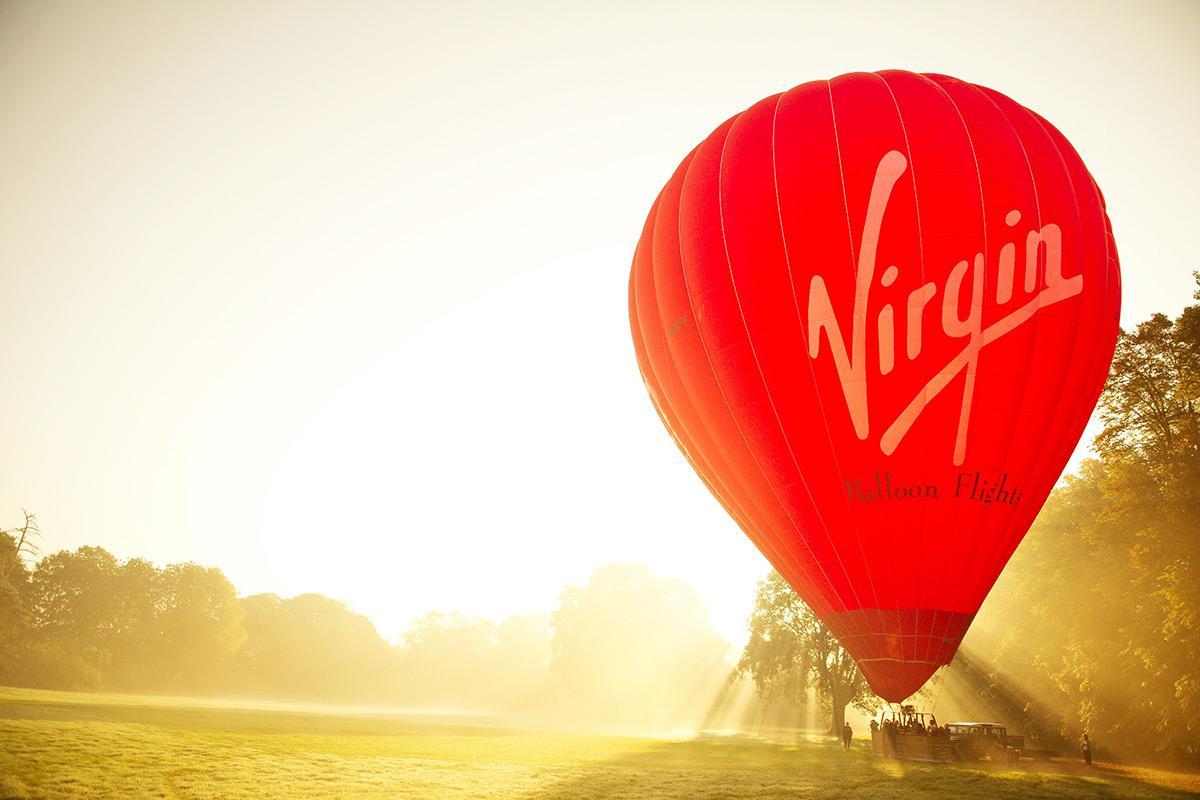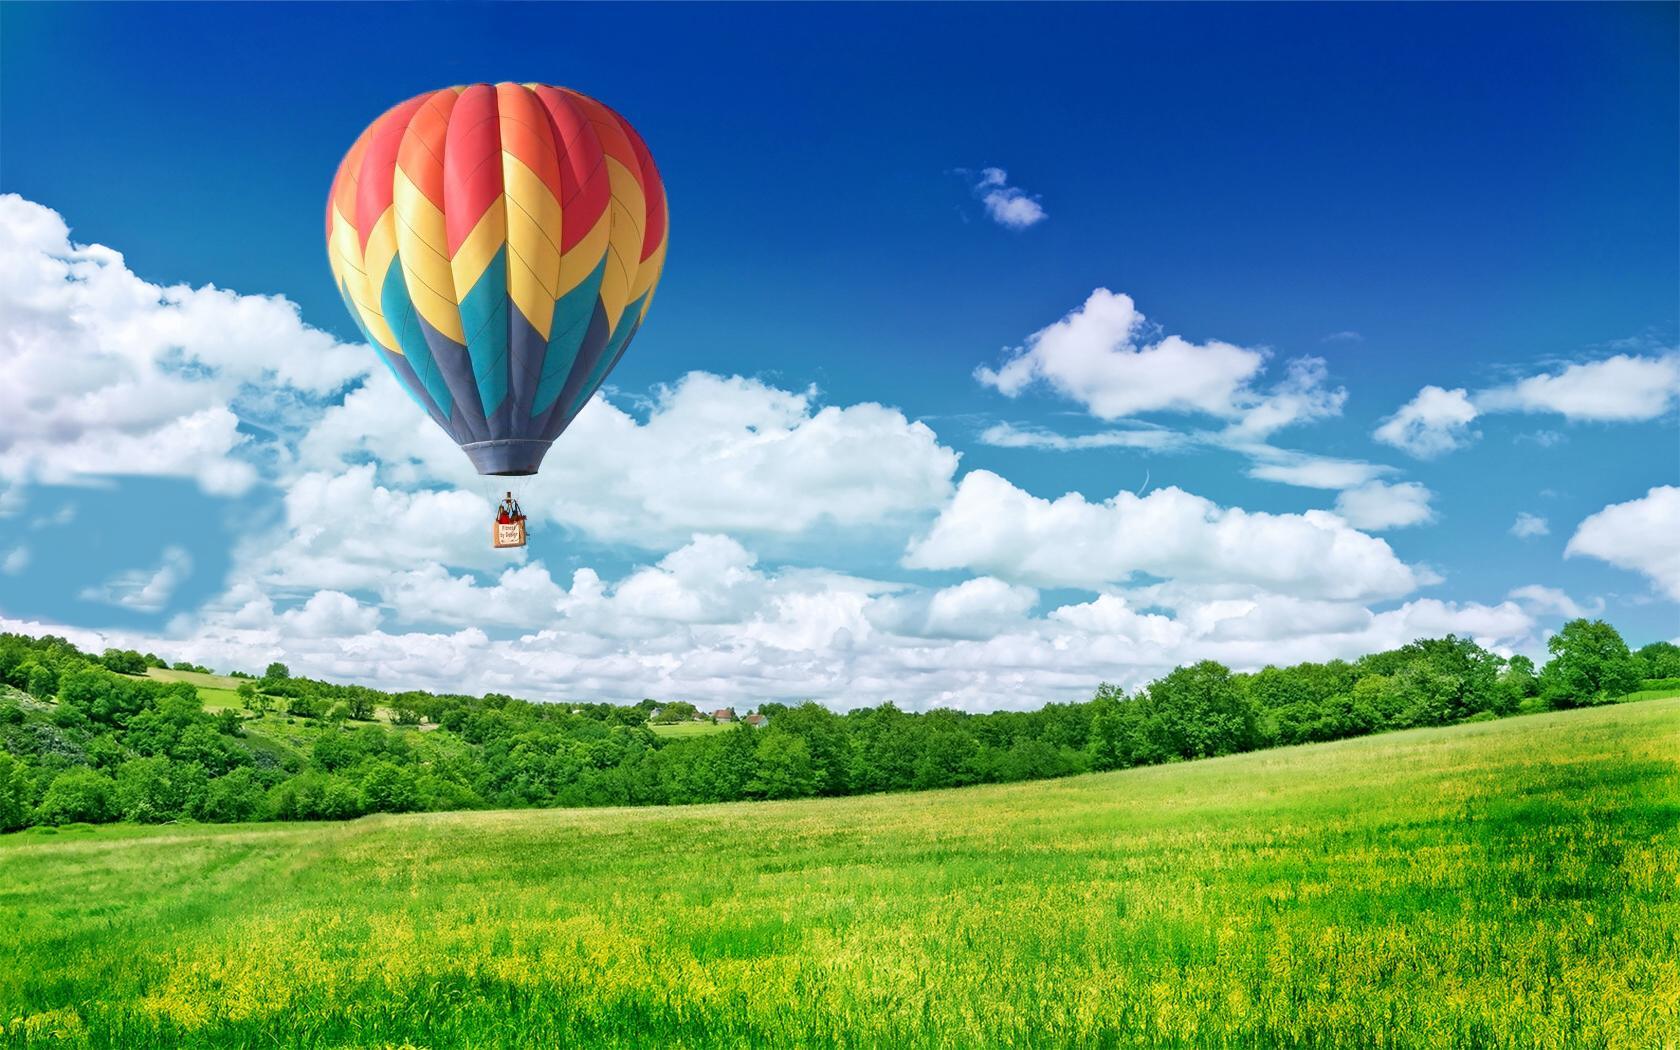The first image is the image on the left, the second image is the image on the right. Analyze the images presented: Is the assertion "There are only two balloons and they are both upright." valid? Answer yes or no. Yes. The first image is the image on the left, the second image is the image on the right. Analyze the images presented: Is the assertion "All hot air balloons have the same company logo." valid? Answer yes or no. No. 